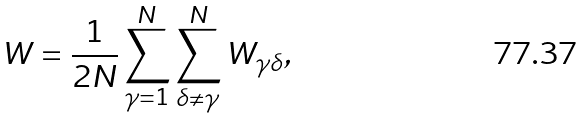Convert formula to latex. <formula><loc_0><loc_0><loc_500><loc_500>W = \frac { 1 } { 2 N } \sum _ { \gamma = 1 } ^ { N } \sum _ { \delta \neq \gamma } ^ { N } W _ { \gamma \delta } ,</formula> 